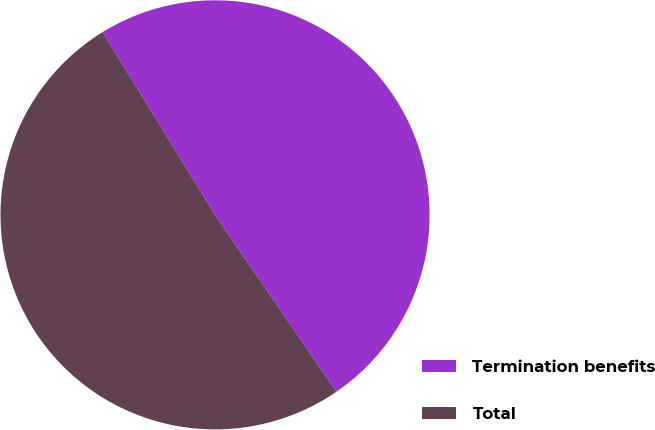<chart> <loc_0><loc_0><loc_500><loc_500><pie_chart><fcel>Termination benefits<fcel>Total<nl><fcel>49.21%<fcel>50.79%<nl></chart> 